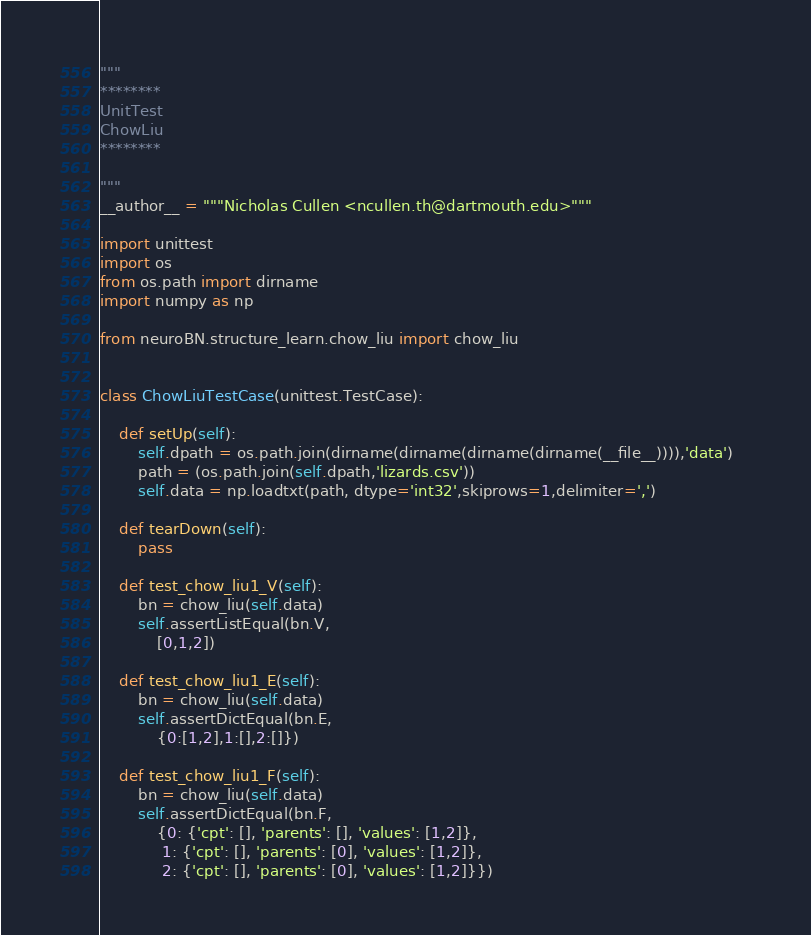Convert code to text. <code><loc_0><loc_0><loc_500><loc_500><_Python_>"""
********
UnitTest
ChowLiu
********

"""
__author__ = """Nicholas Cullen <ncullen.th@dartmouth.edu>"""

import unittest
import os
from os.path import dirname
import numpy as np

from neuroBN.structure_learn.chow_liu import chow_liu


class ChowLiuTestCase(unittest.TestCase):

	def setUp(self):
		self.dpath = os.path.join(dirname(dirname(dirname(dirname(__file__)))),'data')	
		path = (os.path.join(self.dpath,'lizards.csv'))
		self.data = np.loadtxt(path, dtype='int32',skiprows=1,delimiter=',')

	def tearDown(self):
		pass

	def test_chow_liu1_V(self):
		bn = chow_liu(self.data)
		self.assertListEqual(bn.V,
			[0,1,2])

	def test_chow_liu1_E(self):
		bn = chow_liu(self.data)
		self.assertDictEqual(bn.E,
			{0:[1,2],1:[],2:[]})
	
	def test_chow_liu1_F(self):
		bn = chow_liu(self.data)
		self.assertDictEqual(bn.F,
			{0: {'cpt': [], 'parents': [], 'values': [1,2]},
			 1: {'cpt': [], 'parents': [0], 'values': [1,2]},
			 2: {'cpt': [], 'parents': [0], 'values': [1,2]}})</code> 